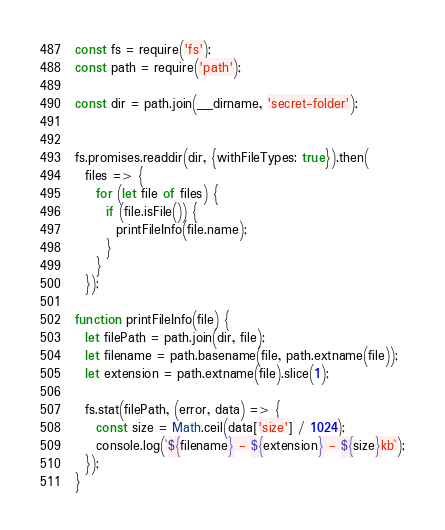Convert code to text. <code><loc_0><loc_0><loc_500><loc_500><_JavaScript_>const fs = require('fs');
const path = require('path');

const dir = path.join(__dirname, 'secret-folder');


fs.promises.readdir(dir, {withFileTypes: true}).then(
  files => {
    for (let file of files) {
      if (file.isFile()) {
        printFileInfo(file.name);
      }
    }
  });

function printFileInfo(file) {
  let filePath = path.join(dir, file);
  let filename = path.basename(file, path.extname(file));
  let extension = path.extname(file).slice(1);

  fs.stat(filePath, (error, data) => {
    const size = Math.ceil(data['size'] / 1024);
    console.log(`${filename} - ${extension} - ${size}kb`);
  });
}
</code> 